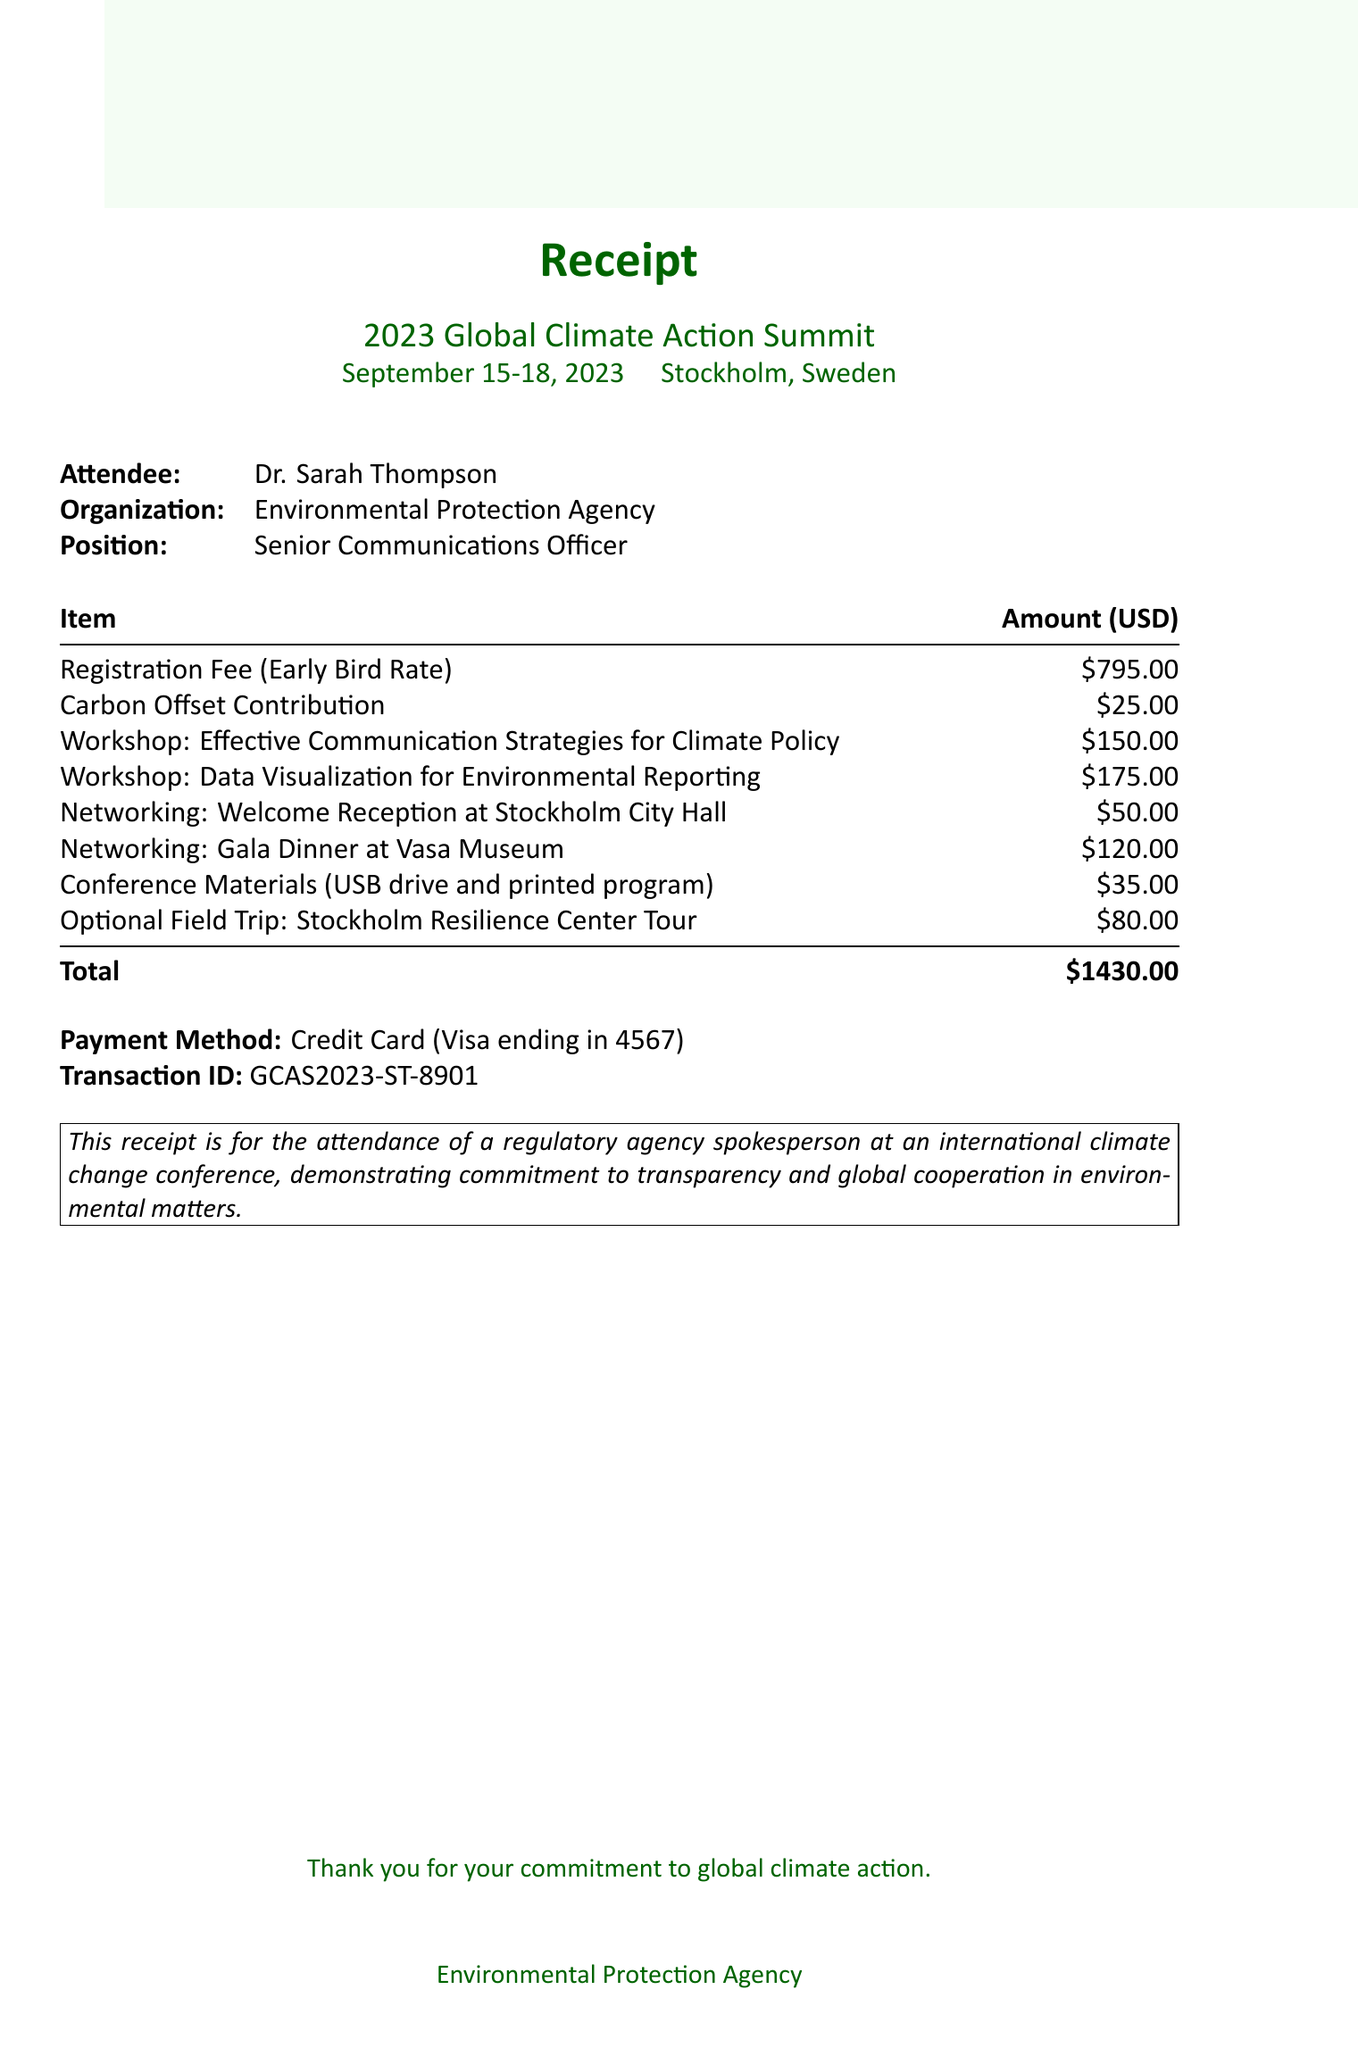What is the name of the event? The name of the event is specified in the document as '2023 Global Climate Action Summit'.
Answer: 2023 Global Climate Action Summit What is the total amount of the receipt? The total amount is detailed in the document reflecting all costs, which adds up to $1430.
Answer: $1430 Who is the attendee from the Environmental Protection Agency? The document clearly identifies the attendee by name, which is 'Dr. Sarah Thompson'.
Answer: Dr. Sarah Thompson What is the price of the optional field trip? The cost for the optional field trip is listed in the breakdown of additional costs, which is $80.
Answer: $80 How much was contributed for carbon offset? The receipt states that the carbon offset contribution was $25.
Answer: $25 What is the date range of the conference? The dates are explicitly mentioned, stating the event occurred from September 15 to September 18, 2023.
Answer: September 15-18, 2023 What workshop costs more than $150? The document shows two workshops; the one costing more than $150 is 'Data Visualization for Environmental Reporting', priced at $175.
Answer: Data Visualization for Environmental Reporting How many networking events are listed in the receipt? The document specifies two networking events, indicating the count perfectly.
Answer: 2 What payment method is mentioned in the receipt? The payment method is explicitly stated as a credit card, specifically a Visa ending in 4567.
Answer: Credit Card (Visa ending in 4567) 